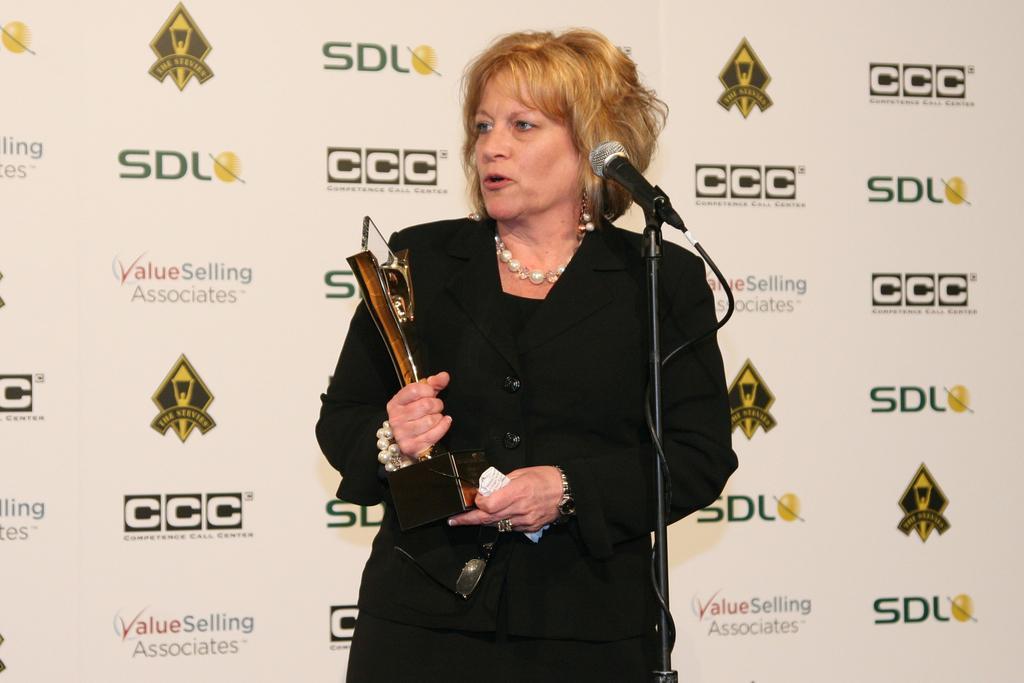Could you give a brief overview of what you see in this image? In the image there is a woman in black dress holding award talking on mic and behind her there is a banner. 